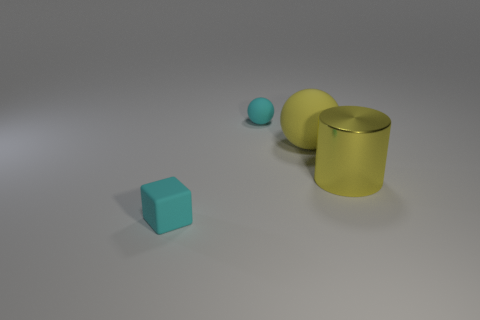Add 2 rubber things. How many objects exist? 6 Subtract 0 purple cylinders. How many objects are left? 4 Subtract all cylinders. How many objects are left? 3 Subtract 1 cylinders. How many cylinders are left? 0 Subtract all green spheres. Subtract all blue cylinders. How many spheres are left? 2 Subtract all cyan balls. How many purple blocks are left? 0 Subtract all cylinders. Subtract all large shiny cylinders. How many objects are left? 2 Add 1 large things. How many large things are left? 3 Add 2 cyan matte things. How many cyan matte things exist? 4 Subtract all cyan spheres. How many spheres are left? 1 